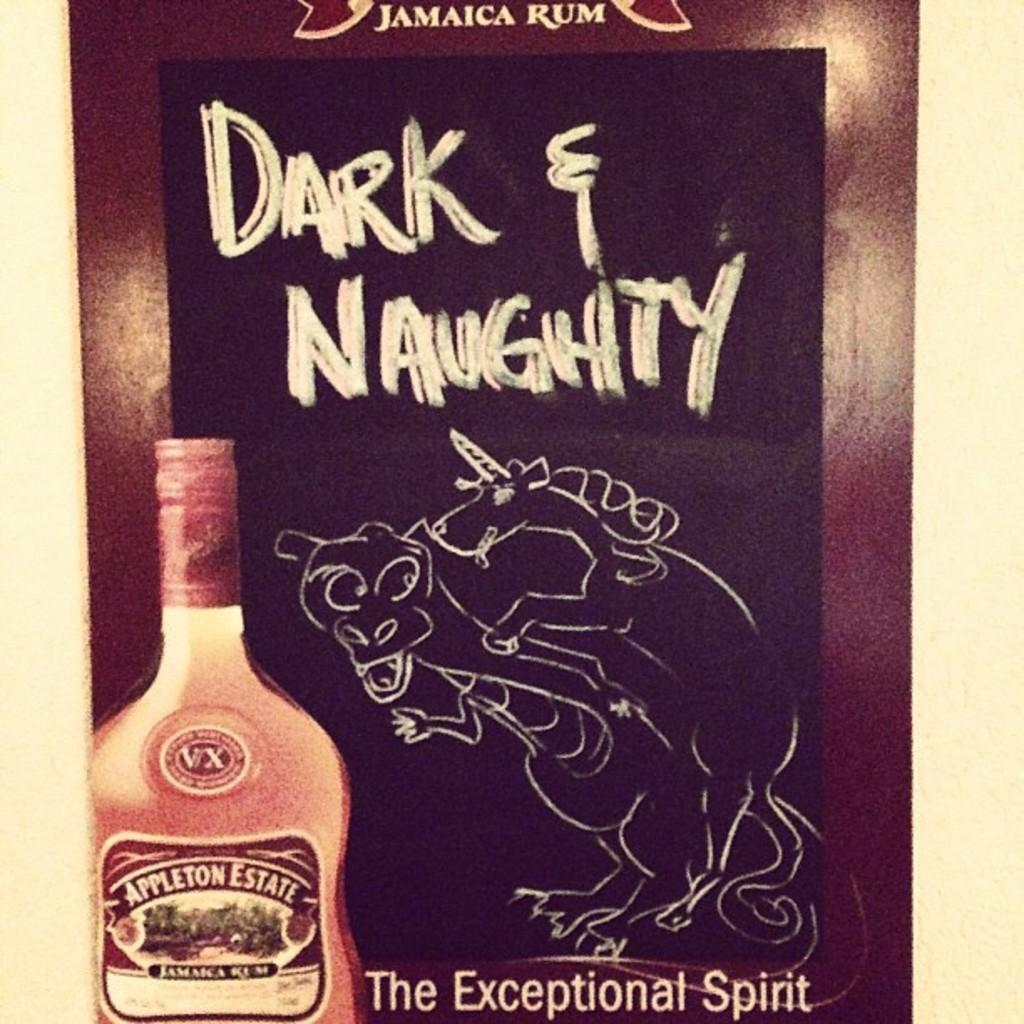<image>
Render a clear and concise summary of the photo. Sign with Dark and Naughty with a chalk drawing of a bull and unicorn going at it 